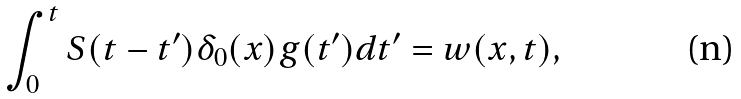Convert formula to latex. <formula><loc_0><loc_0><loc_500><loc_500>\int _ { 0 } ^ { t } S ( t - t ^ { \prime } ) \delta _ { 0 } ( x ) g ( t ^ { \prime } ) d t ^ { \prime } = w ( x , t ) ,</formula> 